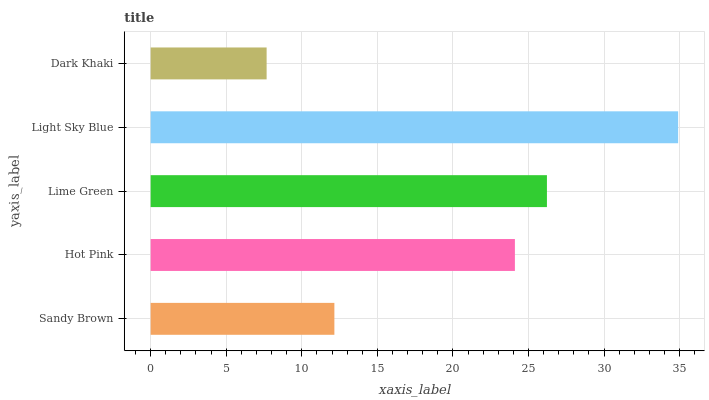Is Dark Khaki the minimum?
Answer yes or no. Yes. Is Light Sky Blue the maximum?
Answer yes or no. Yes. Is Hot Pink the minimum?
Answer yes or no. No. Is Hot Pink the maximum?
Answer yes or no. No. Is Hot Pink greater than Sandy Brown?
Answer yes or no. Yes. Is Sandy Brown less than Hot Pink?
Answer yes or no. Yes. Is Sandy Brown greater than Hot Pink?
Answer yes or no. No. Is Hot Pink less than Sandy Brown?
Answer yes or no. No. Is Hot Pink the high median?
Answer yes or no. Yes. Is Hot Pink the low median?
Answer yes or no. Yes. Is Sandy Brown the high median?
Answer yes or no. No. Is Light Sky Blue the low median?
Answer yes or no. No. 